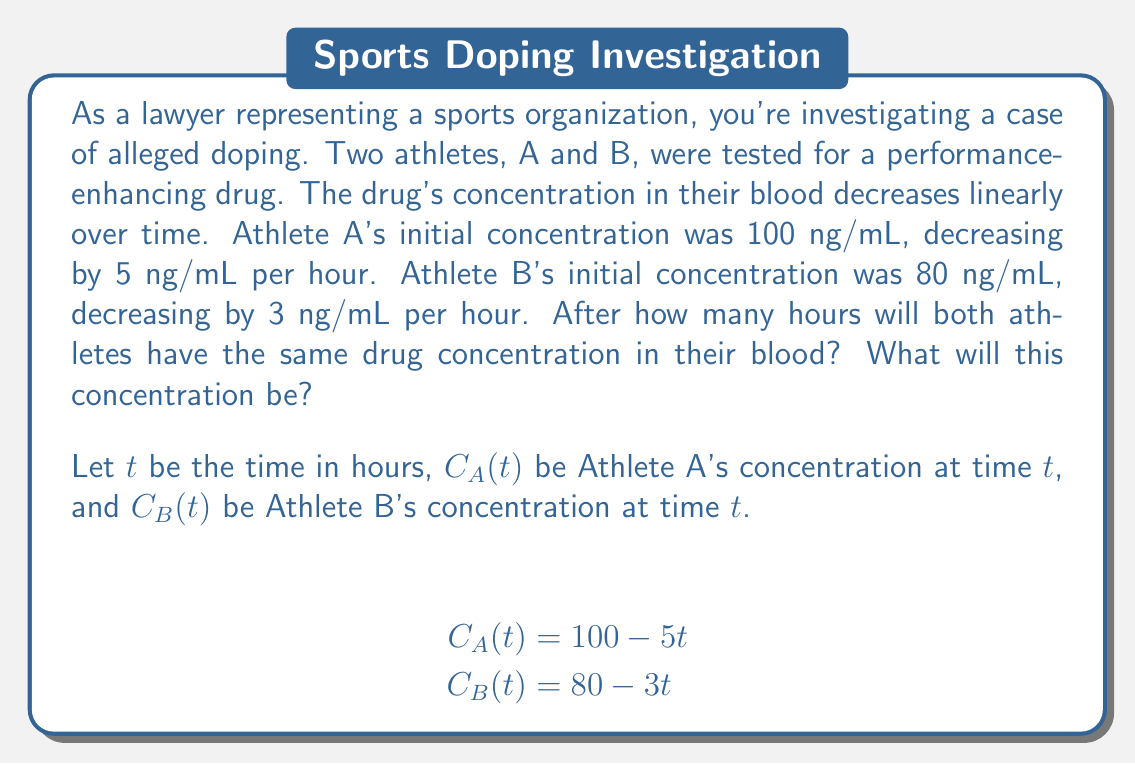Give your solution to this math problem. To solve this problem, we need to find the point where the two concentration functions are equal. This can be done by setting up and solving a system of equations:

1) Set the two concentration functions equal to each other:
   $$C_A(t) = C_B(t)$$
   $$100 - 5t = 80 - 3t$$

2) Solve for $t$:
   $$100 - 5t = 80 - 3t$$
   $$100 - 80 = -5t + 3t$$
   $$20 = -2t$$
   $$t = -10$$

3) The negative time doesn't make sense in this context, so we need to interpret this result. It means that Athlete A's concentration was already lower than Athlete B's at the beginning (t = 0), and they will never have the same concentration in the future.

4) To find Athlete A's concentration at t = 0:
   $$C_A(0) = 100 - 5(0) = 100\text{ ng/mL}$$

5) To find Athlete B's concentration at t = 0:
   $$C_B(0) = 80 - 3(0) = 80\text{ ng/mL}$$

6) To visualize this, we can graph both functions:

[asy]
import graph;
size(200,200);
real f(real x) {return 100-5x;}
real g(real x) {return 80-3x;}
draw(graph(f,0,20),red,"Athlete A");
draw(graph(g,0,26.67),blue,"Athlete B");
xaxis("Time (hours)",arrow=Arrow);
yaxis("Concentration (ng/mL)",arrow=Arrow);
label("Athlete A",(-1,100),red,E);
label("Athlete B",(-1,80),blue,E);
[/asy]

The graph shows that the lines never intersect in the positive time quadrant, confirming our algebraic solution.
Answer: The athletes will never have the same drug concentration. At the initial testing time (t = 0), Athlete A's concentration was already lower at 100 ng/mL compared to Athlete B's 80 ng/mL, and this difference will continue to increase over time. 